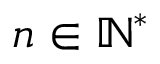<formula> <loc_0><loc_0><loc_500><loc_500>n \in \mathbb { N } ^ { * }</formula> 